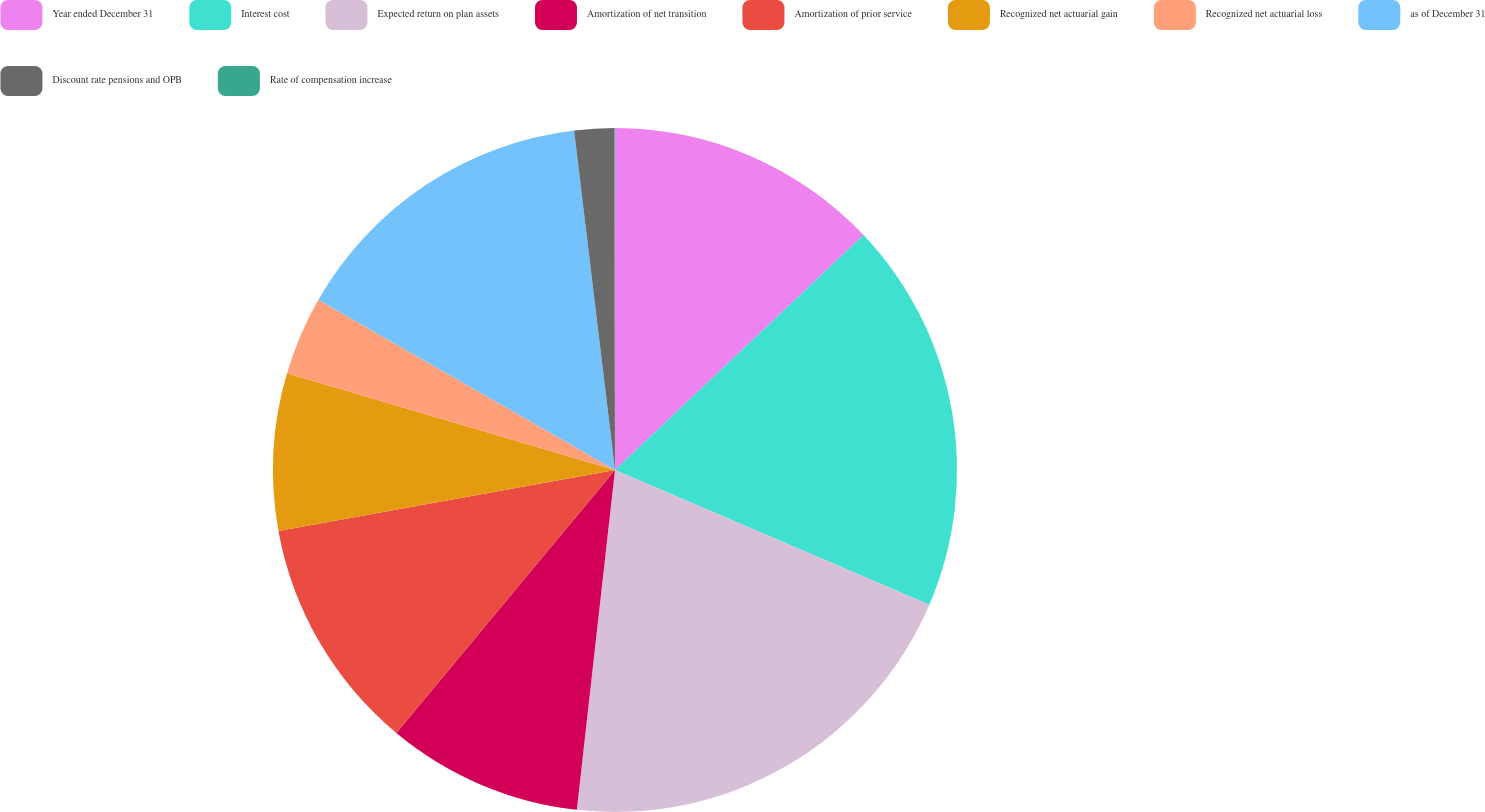<chart> <loc_0><loc_0><loc_500><loc_500><pie_chart><fcel>Year ended December 31<fcel>Interest cost<fcel>Expected return on plan assets<fcel>Amortization of net transition<fcel>Amortization of prior service<fcel>Recognized net actuarial gain<fcel>Recognized net actuarial loss<fcel>as of December 31<fcel>Discount rate pensions and OPB<fcel>Rate of compensation increase<nl><fcel>12.95%<fcel>18.49%<fcel>20.34%<fcel>9.26%<fcel>11.11%<fcel>7.42%<fcel>3.72%<fcel>14.8%<fcel>1.88%<fcel>0.03%<nl></chart> 